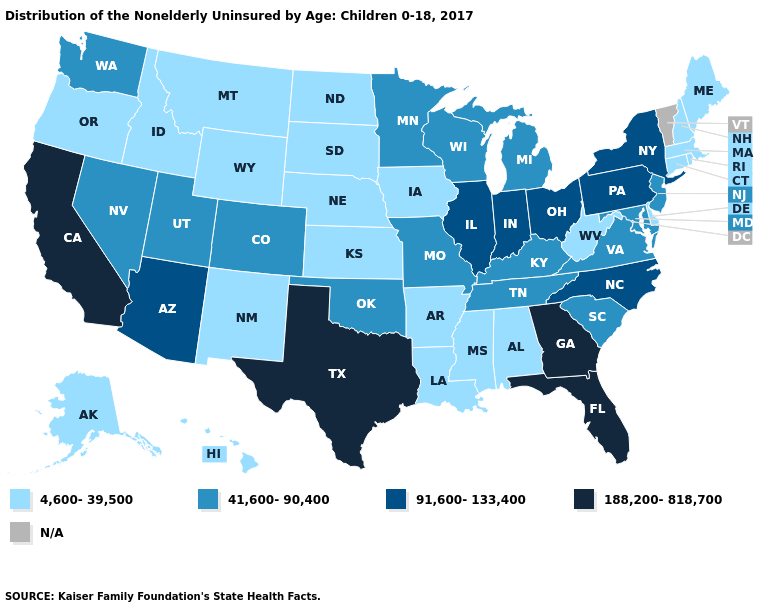What is the highest value in the South ?
Write a very short answer. 188,200-818,700. Does Texas have the highest value in the USA?
Write a very short answer. Yes. Which states have the lowest value in the USA?
Concise answer only. Alabama, Alaska, Arkansas, Connecticut, Delaware, Hawaii, Idaho, Iowa, Kansas, Louisiana, Maine, Massachusetts, Mississippi, Montana, Nebraska, New Hampshire, New Mexico, North Dakota, Oregon, Rhode Island, South Dakota, West Virginia, Wyoming. What is the highest value in the USA?
Give a very brief answer. 188,200-818,700. Name the states that have a value in the range 91,600-133,400?
Short answer required. Arizona, Illinois, Indiana, New York, North Carolina, Ohio, Pennsylvania. Does Massachusetts have the highest value in the USA?
Be succinct. No. What is the value of Minnesota?
Answer briefly. 41,600-90,400. What is the value of Kansas?
Be succinct. 4,600-39,500. What is the value of Wyoming?
Write a very short answer. 4,600-39,500. What is the value of Illinois?
Write a very short answer. 91,600-133,400. Which states have the lowest value in the South?
Quick response, please. Alabama, Arkansas, Delaware, Louisiana, Mississippi, West Virginia. Which states hav the highest value in the South?
Write a very short answer. Florida, Georgia, Texas. What is the value of Kentucky?
Answer briefly. 41,600-90,400. What is the value of Oklahoma?
Give a very brief answer. 41,600-90,400. 